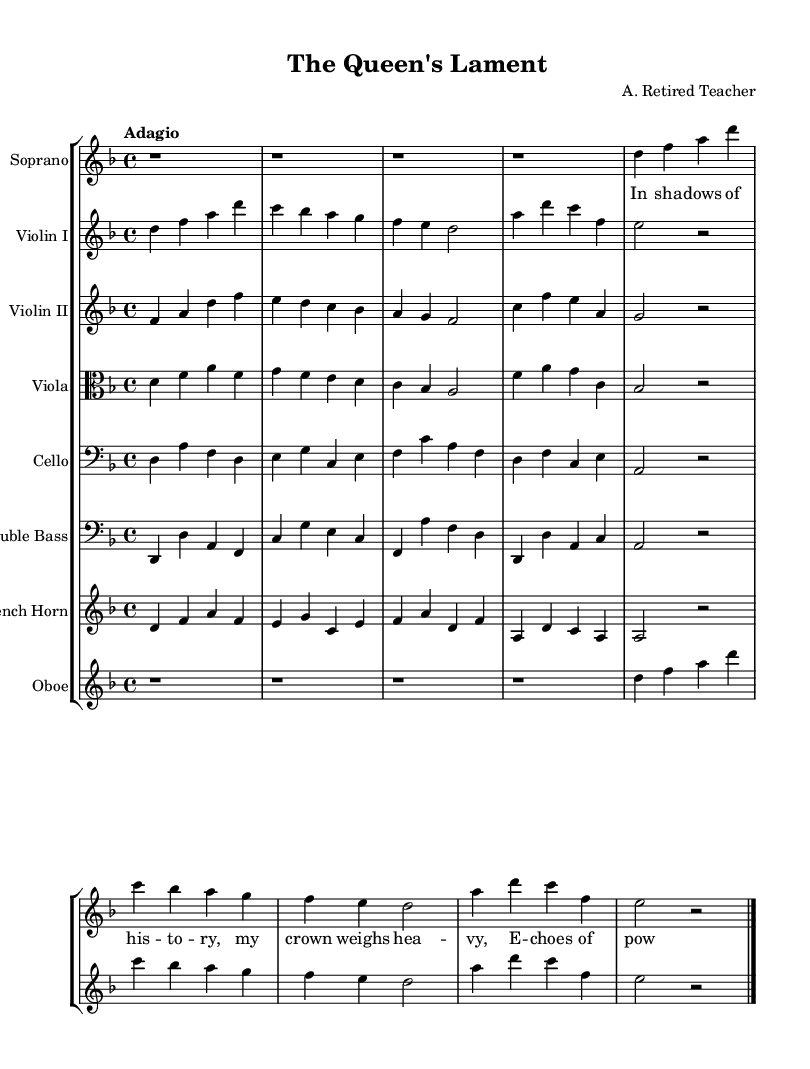What is the key signature of this music? The key signature is indicated by the sharp or flat symbols shown at the beginning of the staff. In this case, there are no sharps or flats, indicating that the key signature is D minor.
Answer: D minor What is the time signature of the piece? The time signature is shown at the start of the staff by two numbers, one above the other. Here, the upper number is 4, and the lower number is 4, indicating there are four beats per measure.
Answer: 4/4 What is the tempo marking indicated for this composition? The tempo marking is located near the beginning of the score, and it states "Adagio," which means to play slowly.
Answer: Adagio How many voices are present in this piece? To determine the number of voices, one looks at the number of staffs with individual parts, indicating separate lines of music. There are seven distinct staffs for the soprano, two violins, viola, cello, double bass, French horn, and oboe, reflecting seven voices.
Answer: Seven Which instrument plays the soprano line? The soprano line is clearly indicated at the top of the score, with its corresponding staff labeled "Soprano." The notes and lyrics beneath it belong to the soprano voice.
Answer: Soprano What is the lyric text for the soprano? The lyrics are displayed beneath the soprano staff in a specific format, showing each syllable aligned with the corresponding notes. They begin with "In sha -- dows of his -- to -- ry, my crown weighs hea -- vy, E -- choes of pow -- er," as shown in the lyrical section.
Answer: In sha -- dows of his -- to -- ry, my crown weighs hea -- vy, E -- choes of pow -- er What instruments are featured in the string section? To find the string instruments, one should look for the staffs labeled accordingly. In this score, the string section includes Violin I, Violin II, Viola, Cello, and Double Bass, indicating all the bass and treble string instruments present.
Answer: Violin I, Violin II, Viola, Cello, Double Bass 